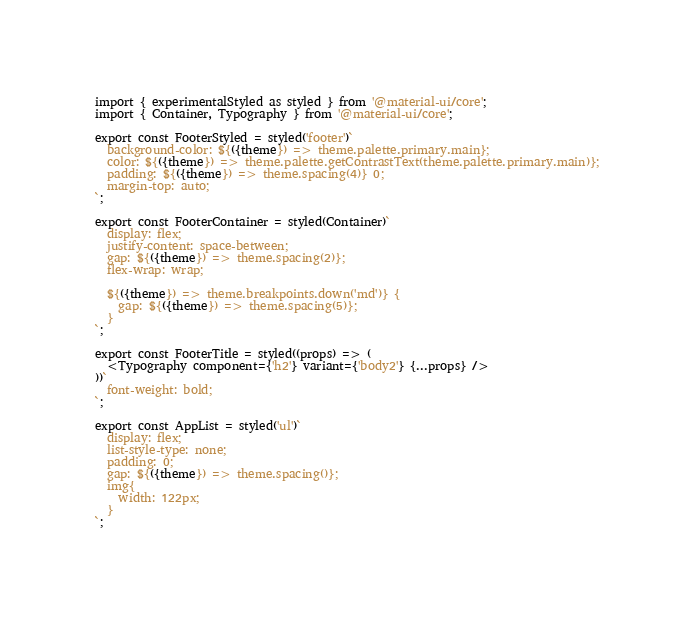<code> <loc_0><loc_0><loc_500><loc_500><_TypeScript_>import { experimentalStyled as styled } from '@material-ui/core';
import { Container, Typography } from '@material-ui/core';

export const FooterStyled = styled('footer')`
  background-color: ${({theme}) => theme.palette.primary.main};
  color: ${({theme}) => theme.palette.getContrastText(theme.palette.primary.main)};
  padding: ${({theme}) => theme.spacing(4)} 0;
  margin-top: auto;
`;

export const FooterContainer = styled(Container)`
  display: flex;
  justify-content: space-between;
  gap: ${({theme}) => theme.spacing(2)};
  flex-wrap: wrap;

  ${({theme}) => theme.breakpoints.down('md')} {
    gap: ${({theme}) => theme.spacing(5)};
  }
`;

export const FooterTitle = styled((props) => (
  <Typography component={'h2'} variant={'body2'} {...props} />
))`
  font-weight: bold;
`;

export const AppList = styled('ul')`
  display: flex;
  list-style-type: none;
  padding: 0;
  gap: ${({theme}) => theme.spacing()};
  img{
    width: 122px;
  }
`;</code> 